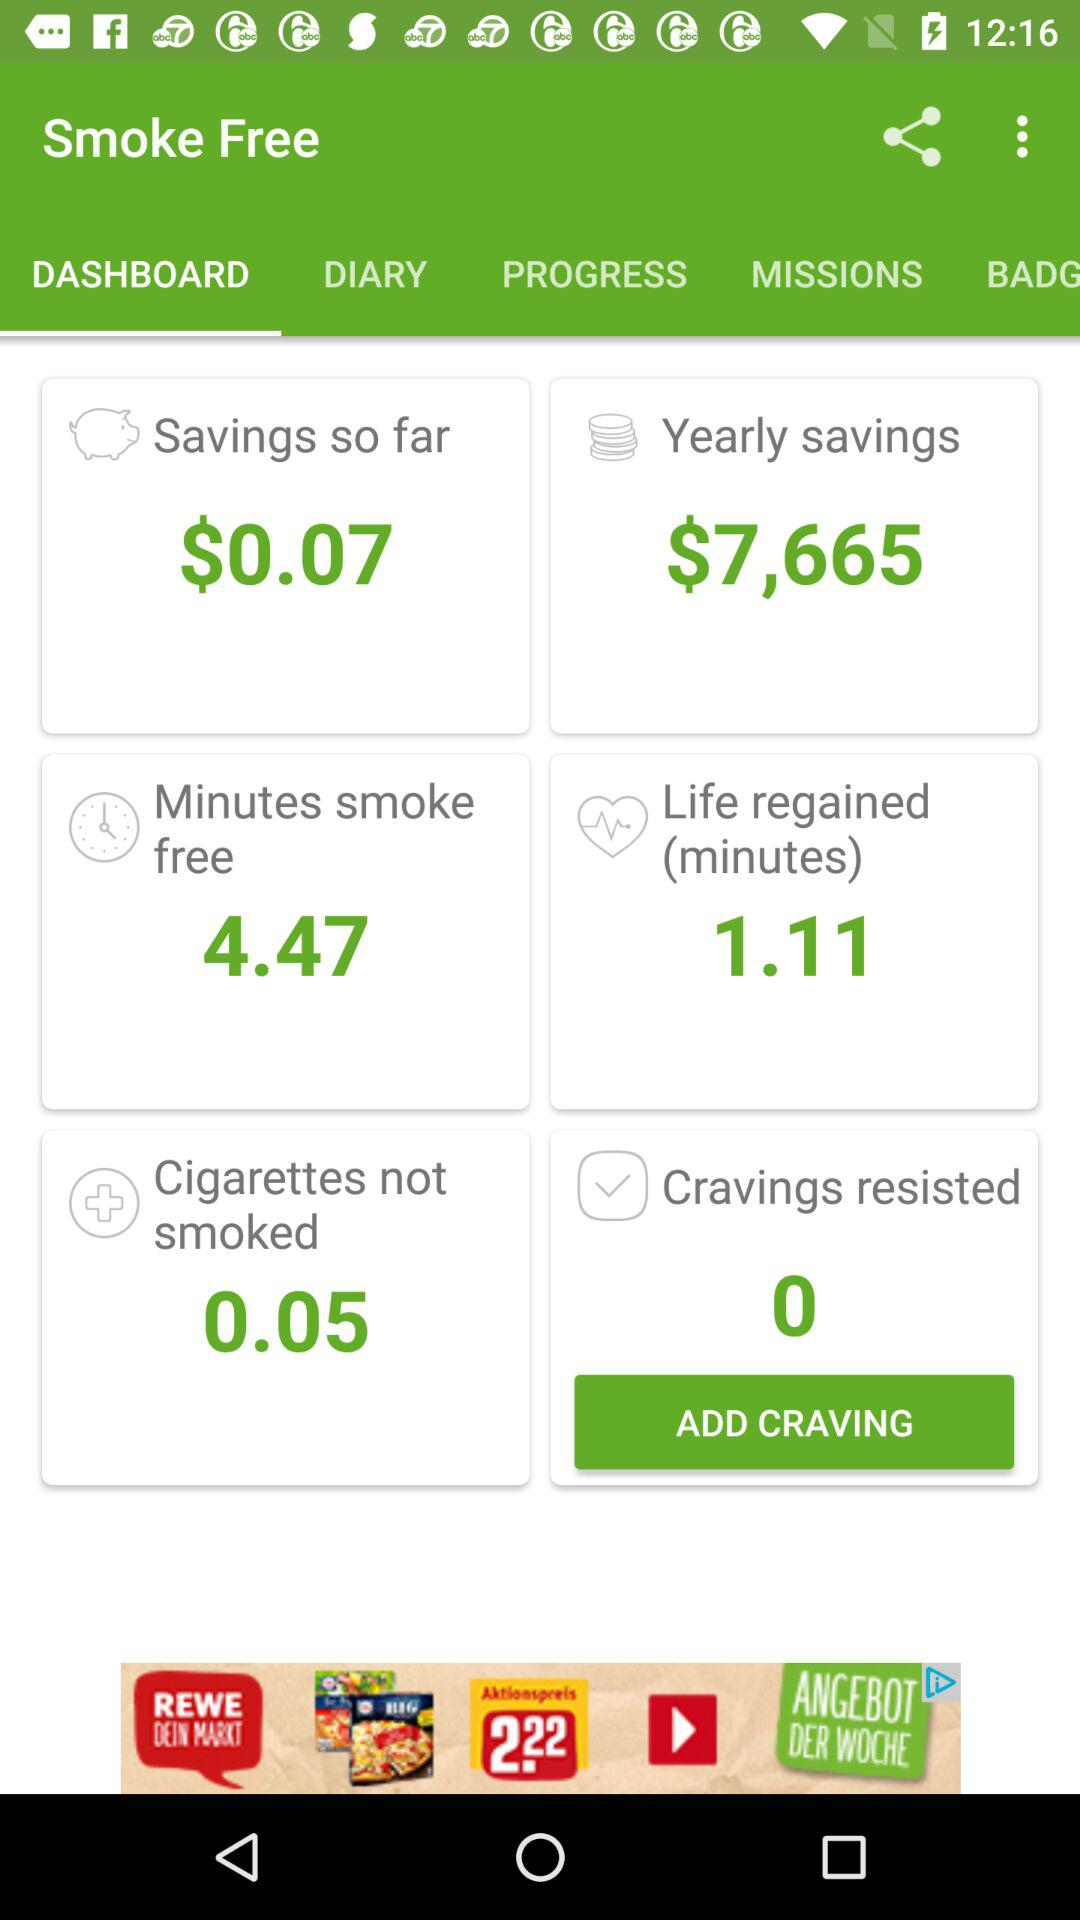How long have we gone without smoking cigarettes? You have gone without smoking cigarettes for 4 minutes and 47 seconds. 